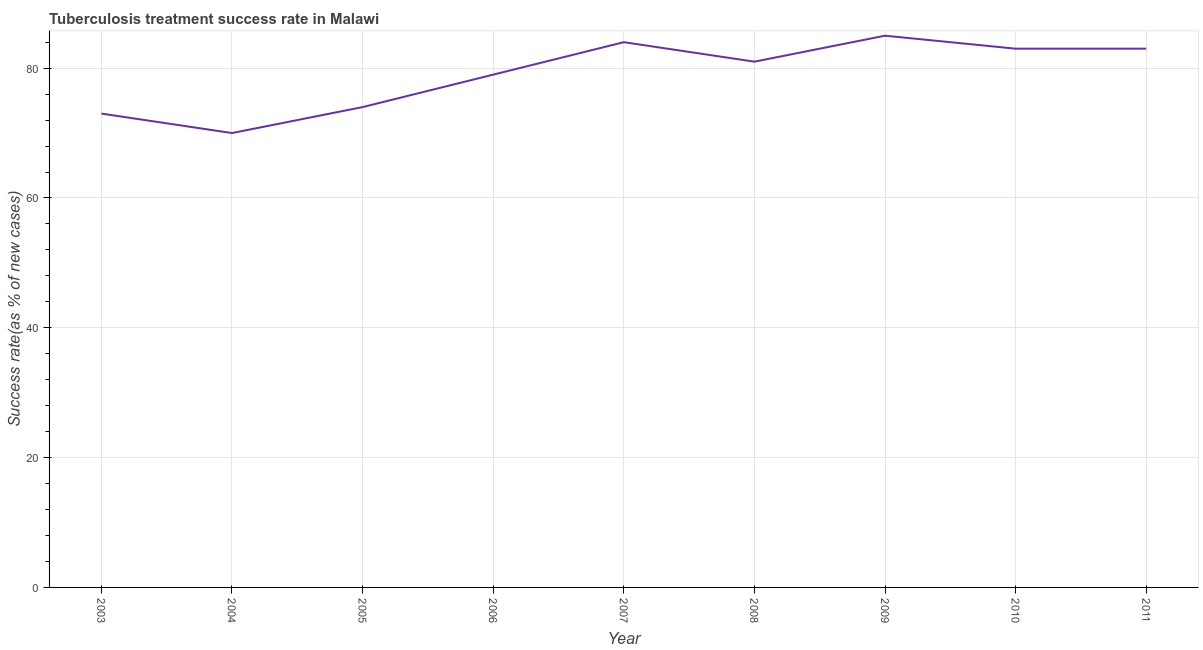What is the tuberculosis treatment success rate in 2009?
Offer a terse response. 85. Across all years, what is the maximum tuberculosis treatment success rate?
Offer a terse response. 85. Across all years, what is the minimum tuberculosis treatment success rate?
Offer a terse response. 70. In which year was the tuberculosis treatment success rate maximum?
Provide a succinct answer. 2009. In which year was the tuberculosis treatment success rate minimum?
Give a very brief answer. 2004. What is the sum of the tuberculosis treatment success rate?
Ensure brevity in your answer.  712. What is the difference between the tuberculosis treatment success rate in 2004 and 2007?
Your answer should be very brief. -14. What is the average tuberculosis treatment success rate per year?
Your answer should be compact. 79.11. What is the ratio of the tuberculosis treatment success rate in 2007 to that in 2009?
Offer a very short reply. 0.99. Is the tuberculosis treatment success rate in 2006 less than that in 2007?
Your response must be concise. Yes. Is the difference between the tuberculosis treatment success rate in 2005 and 2009 greater than the difference between any two years?
Provide a short and direct response. No. What is the difference between the highest and the second highest tuberculosis treatment success rate?
Your response must be concise. 1. Is the sum of the tuberculosis treatment success rate in 2005 and 2010 greater than the maximum tuberculosis treatment success rate across all years?
Give a very brief answer. Yes. What is the difference between the highest and the lowest tuberculosis treatment success rate?
Your answer should be very brief. 15. What is the title of the graph?
Your answer should be very brief. Tuberculosis treatment success rate in Malawi. What is the label or title of the X-axis?
Keep it short and to the point. Year. What is the label or title of the Y-axis?
Your response must be concise. Success rate(as % of new cases). What is the Success rate(as % of new cases) of 2006?
Ensure brevity in your answer.  79. What is the Success rate(as % of new cases) of 2010?
Ensure brevity in your answer.  83. What is the difference between the Success rate(as % of new cases) in 2003 and 2005?
Ensure brevity in your answer.  -1. What is the difference between the Success rate(as % of new cases) in 2003 and 2006?
Make the answer very short. -6. What is the difference between the Success rate(as % of new cases) in 2003 and 2007?
Give a very brief answer. -11. What is the difference between the Success rate(as % of new cases) in 2003 and 2009?
Offer a terse response. -12. What is the difference between the Success rate(as % of new cases) in 2003 and 2010?
Your answer should be very brief. -10. What is the difference between the Success rate(as % of new cases) in 2003 and 2011?
Provide a short and direct response. -10. What is the difference between the Success rate(as % of new cases) in 2004 and 2006?
Offer a very short reply. -9. What is the difference between the Success rate(as % of new cases) in 2004 and 2007?
Your response must be concise. -14. What is the difference between the Success rate(as % of new cases) in 2004 and 2008?
Make the answer very short. -11. What is the difference between the Success rate(as % of new cases) in 2004 and 2009?
Give a very brief answer. -15. What is the difference between the Success rate(as % of new cases) in 2004 and 2011?
Make the answer very short. -13. What is the difference between the Success rate(as % of new cases) in 2005 and 2006?
Your answer should be very brief. -5. What is the difference between the Success rate(as % of new cases) in 2005 and 2007?
Your response must be concise. -10. What is the difference between the Success rate(as % of new cases) in 2005 and 2009?
Make the answer very short. -11. What is the difference between the Success rate(as % of new cases) in 2005 and 2010?
Make the answer very short. -9. What is the difference between the Success rate(as % of new cases) in 2006 and 2008?
Offer a terse response. -2. What is the difference between the Success rate(as % of new cases) in 2006 and 2009?
Offer a terse response. -6. What is the difference between the Success rate(as % of new cases) in 2007 and 2008?
Provide a short and direct response. 3. What is the difference between the Success rate(as % of new cases) in 2007 and 2009?
Provide a short and direct response. -1. What is the difference between the Success rate(as % of new cases) in 2007 and 2010?
Provide a succinct answer. 1. What is the difference between the Success rate(as % of new cases) in 2008 and 2010?
Keep it short and to the point. -2. What is the difference between the Success rate(as % of new cases) in 2008 and 2011?
Offer a very short reply. -2. What is the difference between the Success rate(as % of new cases) in 2009 and 2011?
Your answer should be very brief. 2. What is the ratio of the Success rate(as % of new cases) in 2003 to that in 2004?
Keep it short and to the point. 1.04. What is the ratio of the Success rate(as % of new cases) in 2003 to that in 2006?
Keep it short and to the point. 0.92. What is the ratio of the Success rate(as % of new cases) in 2003 to that in 2007?
Your answer should be very brief. 0.87. What is the ratio of the Success rate(as % of new cases) in 2003 to that in 2008?
Make the answer very short. 0.9. What is the ratio of the Success rate(as % of new cases) in 2003 to that in 2009?
Offer a very short reply. 0.86. What is the ratio of the Success rate(as % of new cases) in 2004 to that in 2005?
Give a very brief answer. 0.95. What is the ratio of the Success rate(as % of new cases) in 2004 to that in 2006?
Provide a short and direct response. 0.89. What is the ratio of the Success rate(as % of new cases) in 2004 to that in 2007?
Your answer should be compact. 0.83. What is the ratio of the Success rate(as % of new cases) in 2004 to that in 2008?
Make the answer very short. 0.86. What is the ratio of the Success rate(as % of new cases) in 2004 to that in 2009?
Your answer should be compact. 0.82. What is the ratio of the Success rate(as % of new cases) in 2004 to that in 2010?
Provide a short and direct response. 0.84. What is the ratio of the Success rate(as % of new cases) in 2004 to that in 2011?
Give a very brief answer. 0.84. What is the ratio of the Success rate(as % of new cases) in 2005 to that in 2006?
Your answer should be very brief. 0.94. What is the ratio of the Success rate(as % of new cases) in 2005 to that in 2007?
Your response must be concise. 0.88. What is the ratio of the Success rate(as % of new cases) in 2005 to that in 2008?
Make the answer very short. 0.91. What is the ratio of the Success rate(as % of new cases) in 2005 to that in 2009?
Ensure brevity in your answer.  0.87. What is the ratio of the Success rate(as % of new cases) in 2005 to that in 2010?
Ensure brevity in your answer.  0.89. What is the ratio of the Success rate(as % of new cases) in 2005 to that in 2011?
Provide a short and direct response. 0.89. What is the ratio of the Success rate(as % of new cases) in 2006 to that in 2009?
Your response must be concise. 0.93. What is the ratio of the Success rate(as % of new cases) in 2006 to that in 2010?
Provide a short and direct response. 0.95. What is the ratio of the Success rate(as % of new cases) in 2007 to that in 2008?
Your response must be concise. 1.04. What is the ratio of the Success rate(as % of new cases) in 2008 to that in 2009?
Provide a succinct answer. 0.95. What is the ratio of the Success rate(as % of new cases) in 2009 to that in 2010?
Your response must be concise. 1.02. What is the ratio of the Success rate(as % of new cases) in 2009 to that in 2011?
Offer a very short reply. 1.02. 